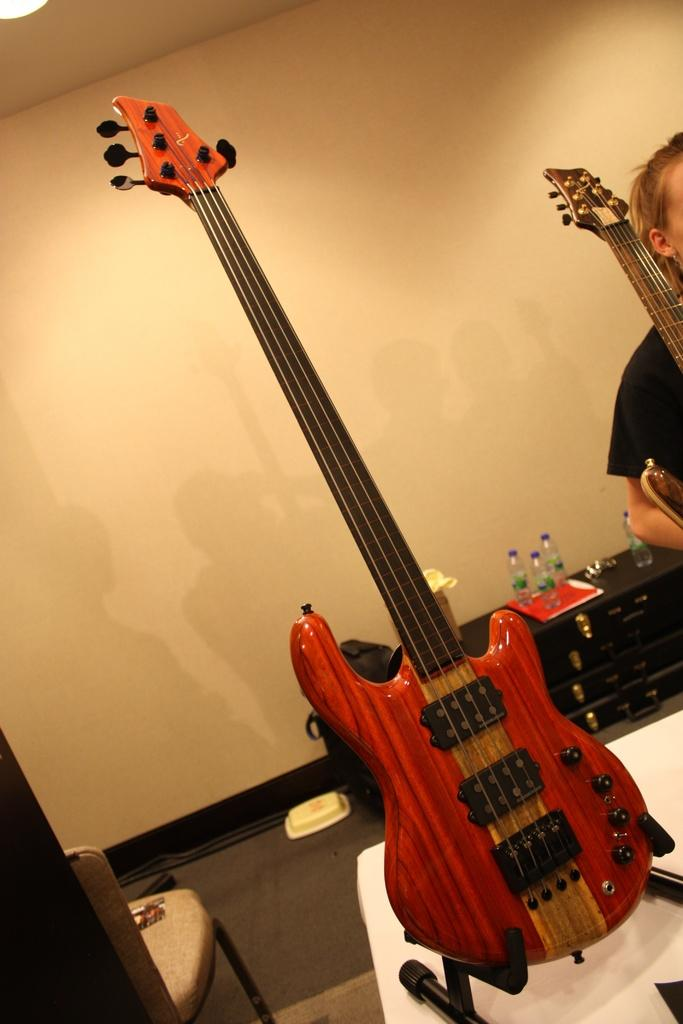What is the main object in the middle of the image? There is a guitar in the middle of the image. Who or what is on the right side of the image? There is a person on the right side of the image. What can be seen in the background of the image? There are bottles and a wall in the background of the image. What piece of furniture is on the left side of the image? There is a chair on the left side of the image. What type of map is being used for digestion in the image? There is no map or digestion activity present in the image. 